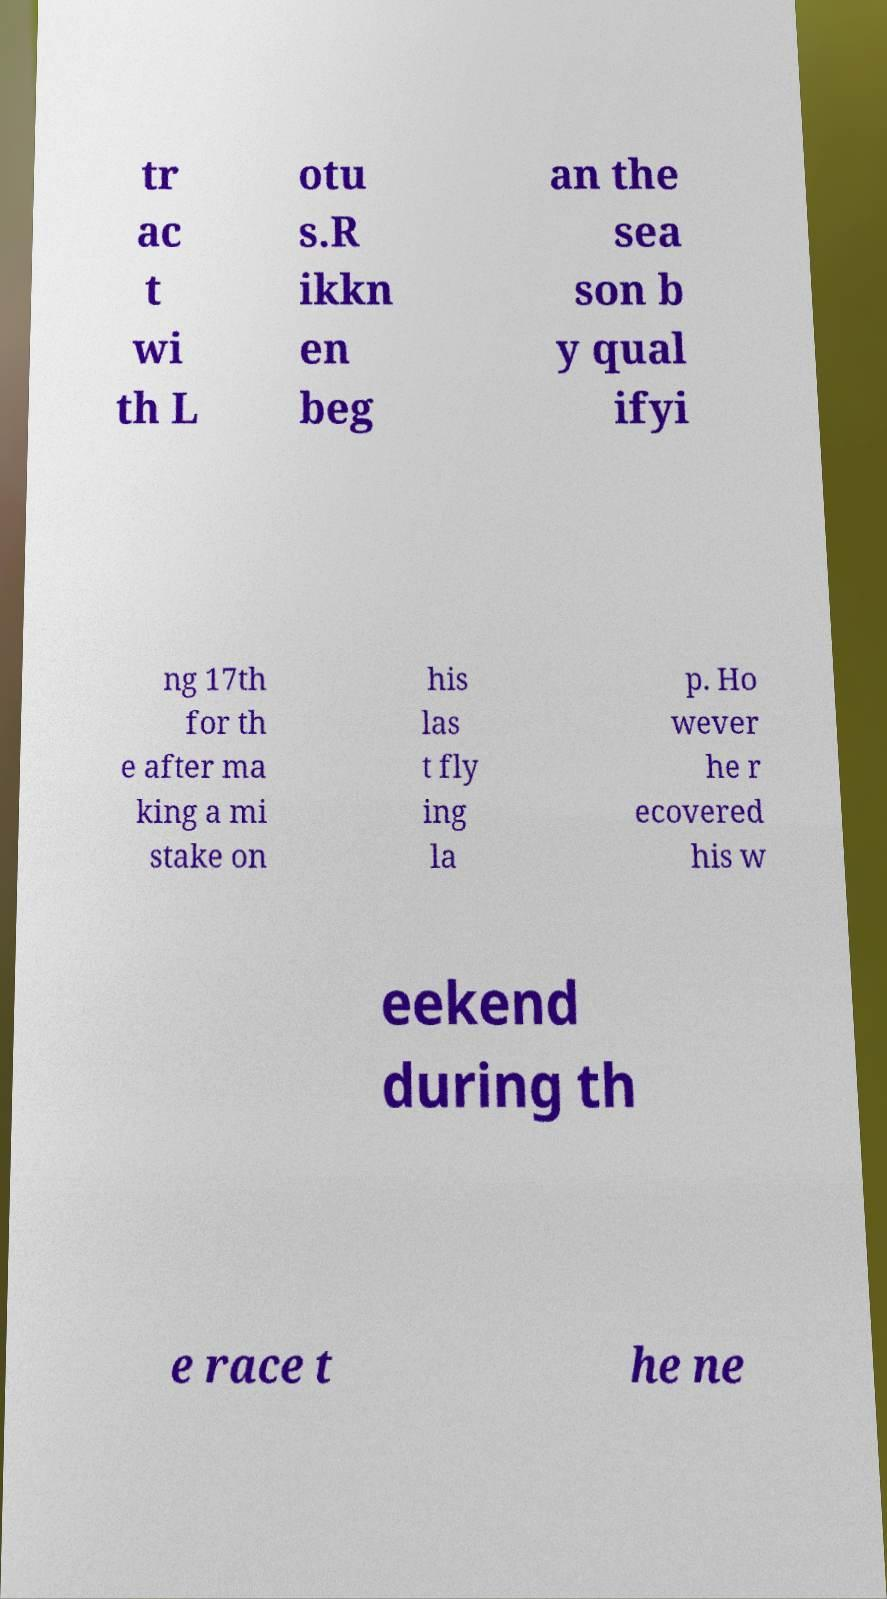What messages or text are displayed in this image? I need them in a readable, typed format. tr ac t wi th L otu s.R ikkn en beg an the sea son b y qual ifyi ng 17th for th e after ma king a mi stake on his las t fly ing la p. Ho wever he r ecovered his w eekend during th e race t he ne 